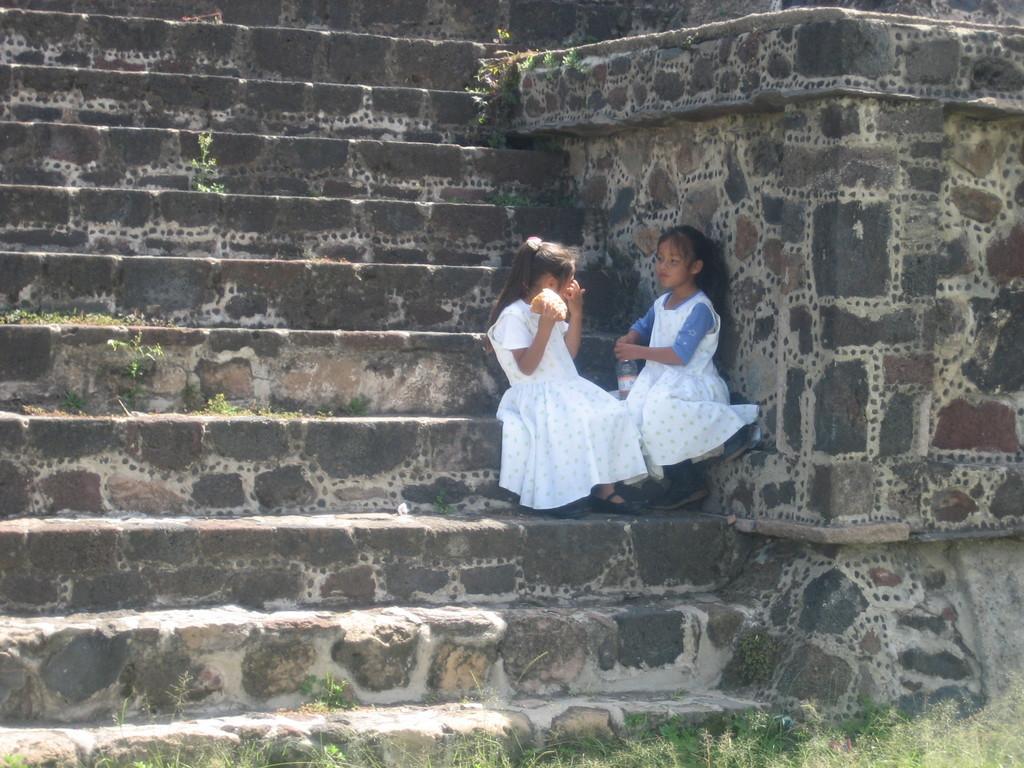Please provide a concise description of this image. In this image I see 2 girls who are sitting over here and I see that there is a bottle over here and I see the steps and I see the wall over here and I see the plants. 